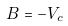Convert formula to latex. <formula><loc_0><loc_0><loc_500><loc_500>B = - V _ { c }</formula> 